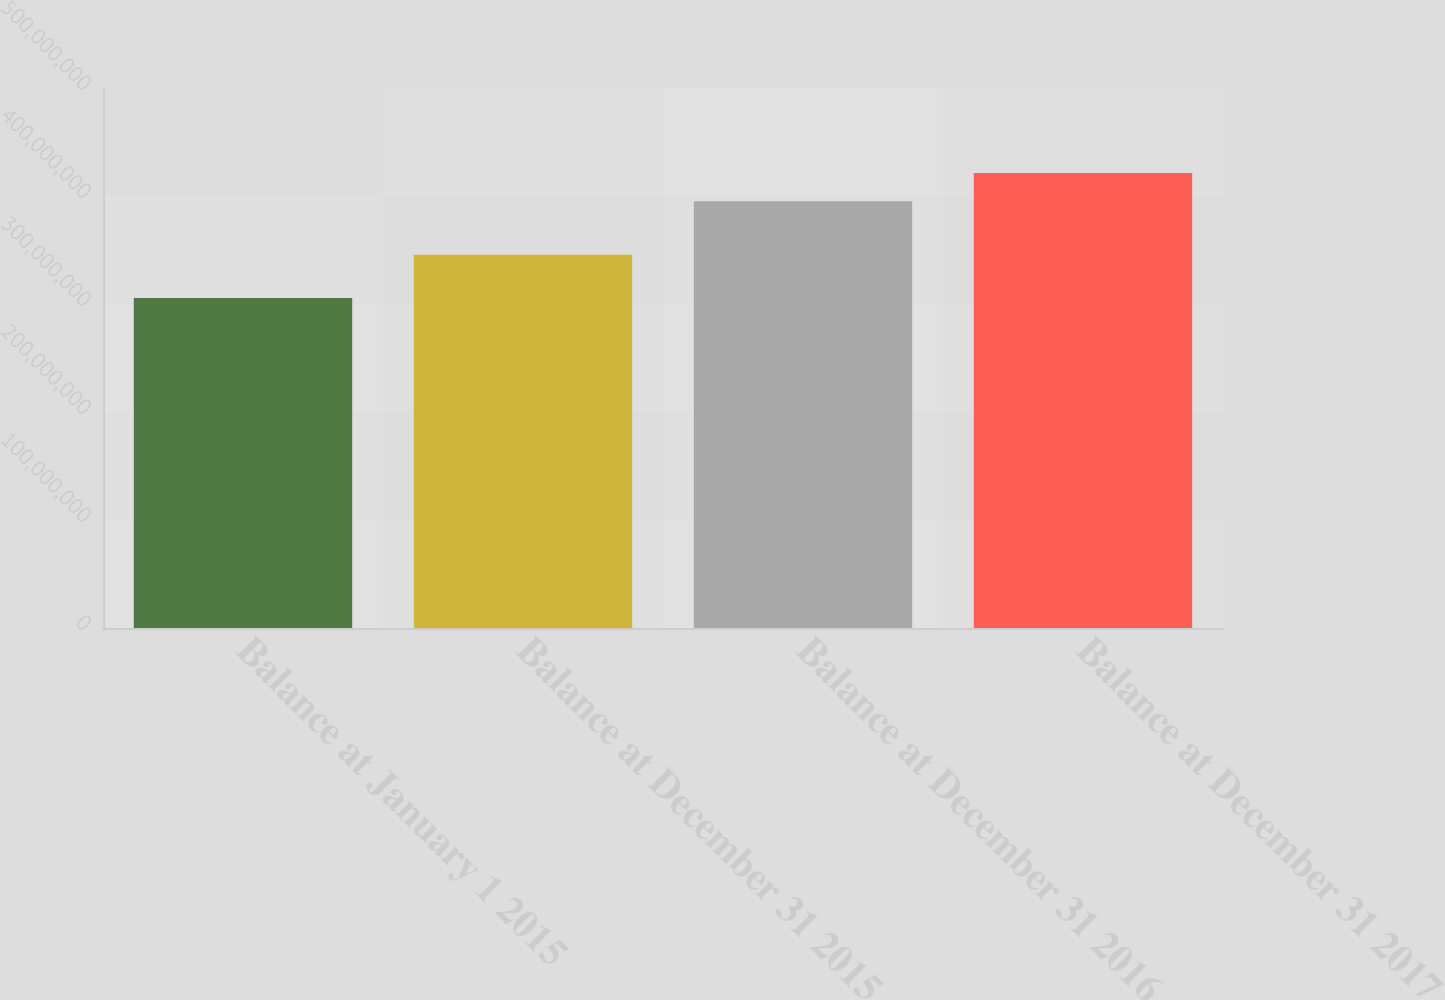Convert chart to OTSL. <chart><loc_0><loc_0><loc_500><loc_500><bar_chart><fcel>Balance at January 1 2015<fcel>Balance at December 31 2015<fcel>Balance at December 31 2016<fcel>Balance at December 31 2017<nl><fcel>3.05534e+08<fcel>3.45637e+08<fcel>3.9511e+08<fcel>4.21222e+08<nl></chart> 